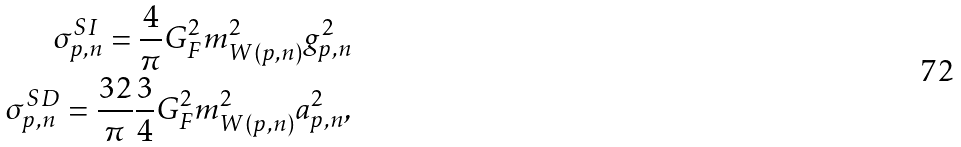Convert formula to latex. <formula><loc_0><loc_0><loc_500><loc_500>\sigma ^ { S I } _ { p , n } = \frac { 4 } { \pi } G _ { F } ^ { 2 } m _ { W ( p , n ) } ^ { 2 } g _ { p , n } ^ { 2 } \\ \sigma ^ { S D } _ { p , n } = \frac { 3 2 } { \pi } \frac { 3 } { 4 } G _ { F } ^ { 2 } m _ { W ( p , n ) } ^ { 2 } a _ { p , n } ^ { 2 } ,</formula> 